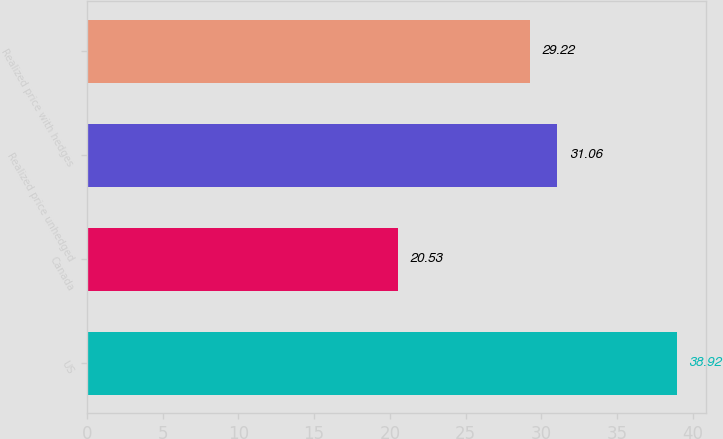<chart> <loc_0><loc_0><loc_500><loc_500><bar_chart><fcel>US<fcel>Canada<fcel>Realized price unhedged<fcel>Realized price with hedges<nl><fcel>38.92<fcel>20.53<fcel>31.06<fcel>29.22<nl></chart> 